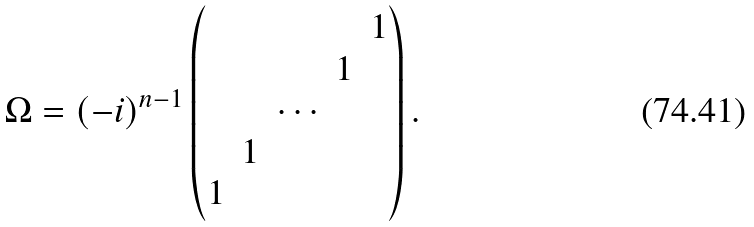<formula> <loc_0><loc_0><loc_500><loc_500>\Omega = ( - i ) ^ { n - 1 } \begin{pmatrix} & & & & 1 \\ & & & 1 \\ & & \cdots \\ & 1 \\ 1 \end{pmatrix} .</formula> 